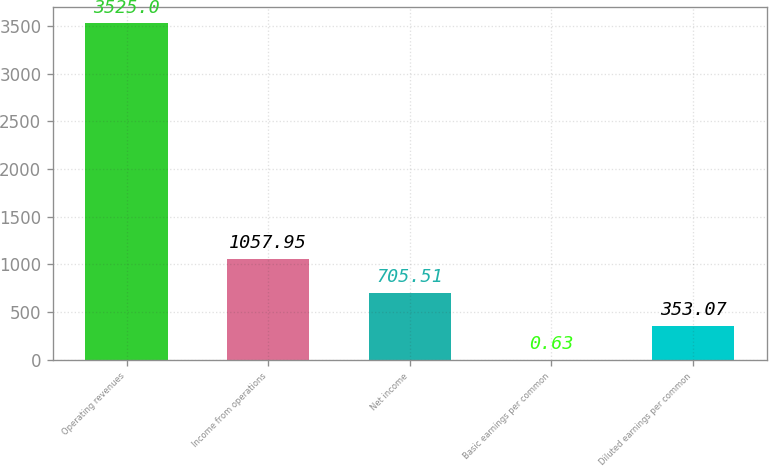<chart> <loc_0><loc_0><loc_500><loc_500><bar_chart><fcel>Operating revenues<fcel>Income from operations<fcel>Net income<fcel>Basic earnings per common<fcel>Diluted earnings per common<nl><fcel>3525<fcel>1057.95<fcel>705.51<fcel>0.63<fcel>353.07<nl></chart> 